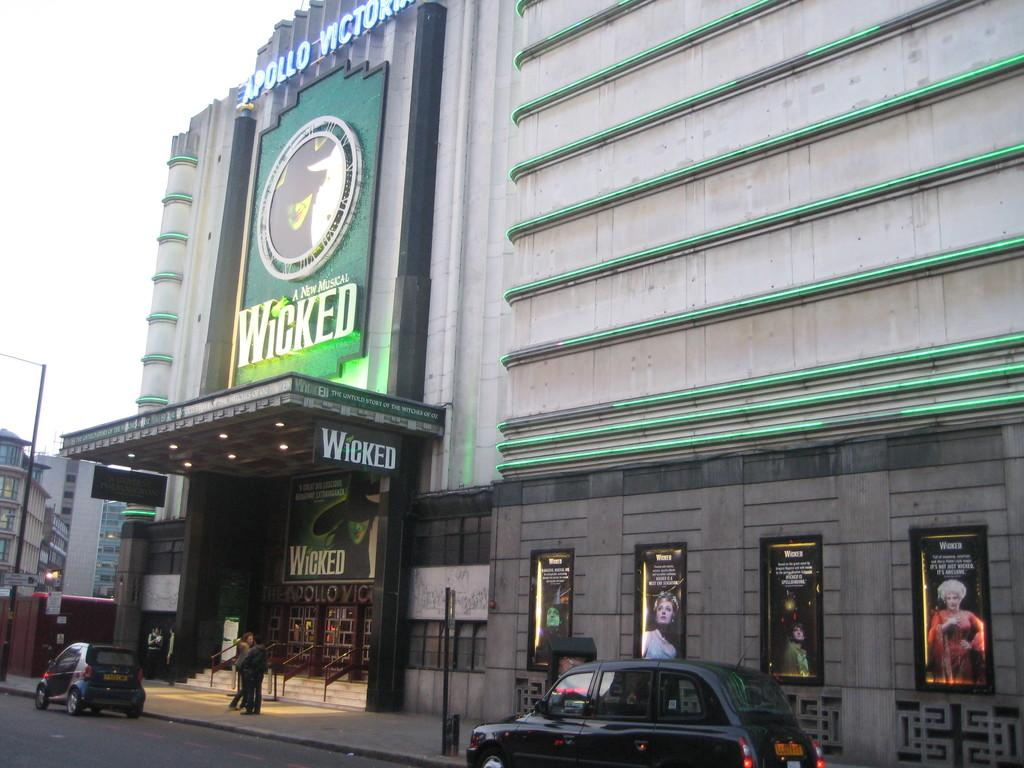<image>
Provide a brief description of the given image. The outside of a theater that is showing the play Wicked. 